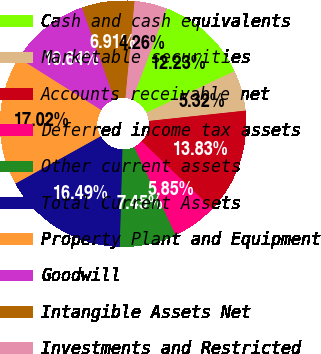Convert chart. <chart><loc_0><loc_0><loc_500><loc_500><pie_chart><fcel>Cash and cash equivalents<fcel>Marketable securities<fcel>Accounts receivable net<fcel>Deferred income tax assets<fcel>Other current assets<fcel>Total Current Assets<fcel>Property Plant and Equipment<fcel>Goodwill<fcel>Intangible Assets Net<fcel>Investments and Restricted<nl><fcel>12.23%<fcel>5.32%<fcel>13.83%<fcel>5.85%<fcel>7.45%<fcel>16.49%<fcel>17.02%<fcel>10.64%<fcel>6.91%<fcel>4.26%<nl></chart> 